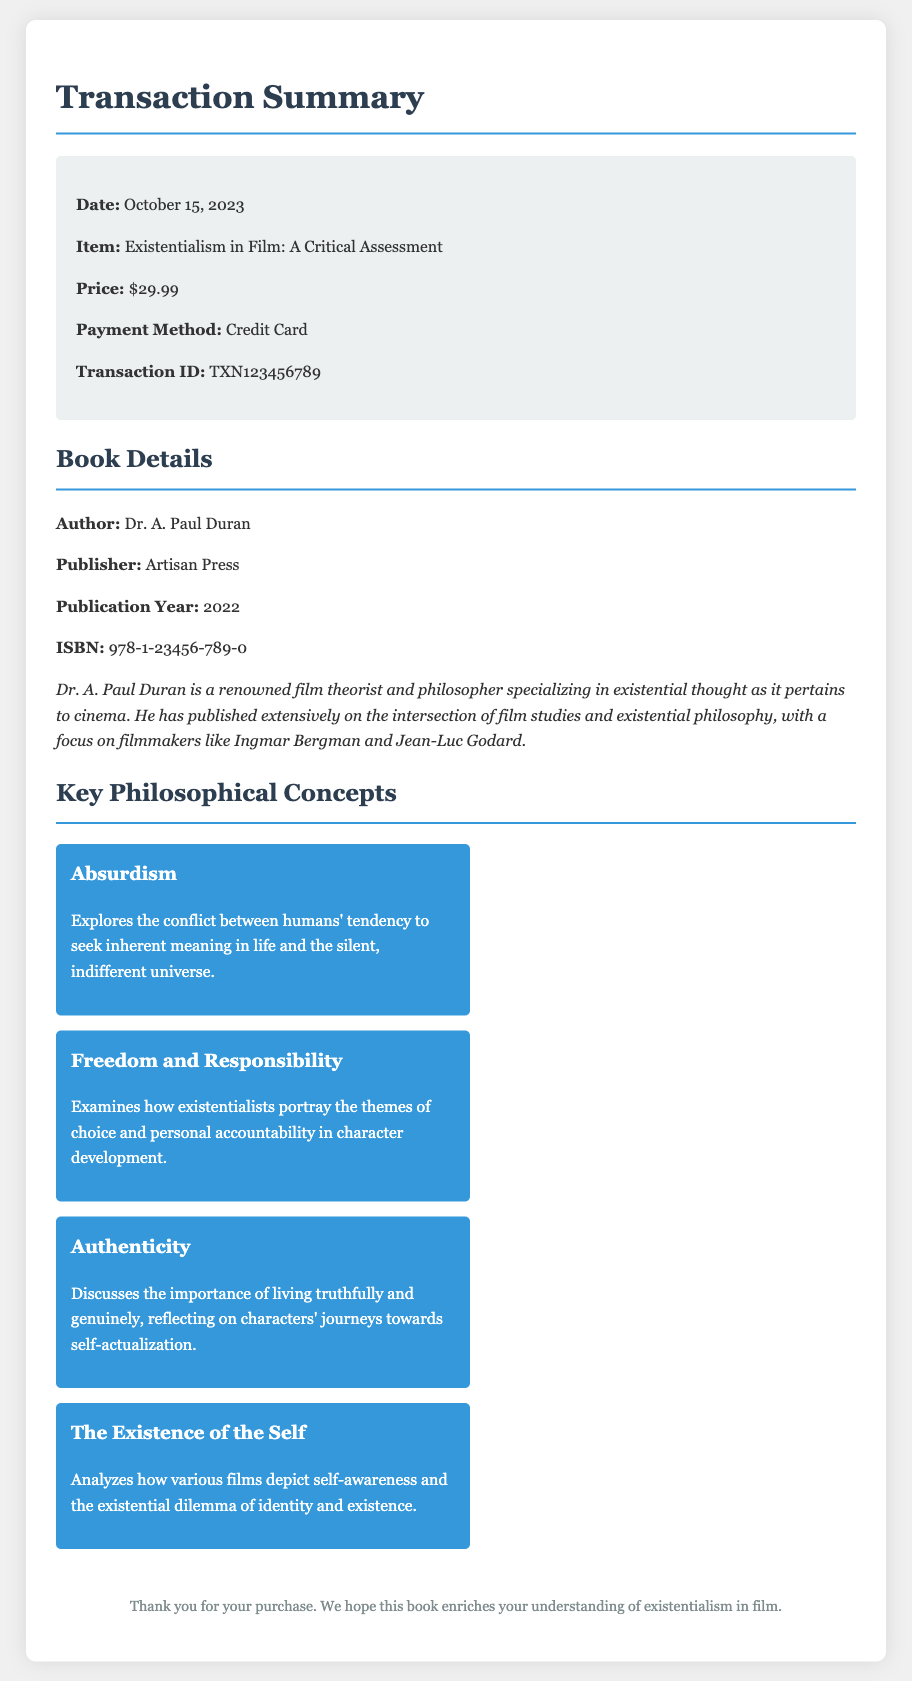What is the transaction date? The transaction date is explicitly mentioned in the document under the transaction details section.
Answer: October 15, 2023 Who is the author of the book? The author of the book is highlighted in the book details section of the document.
Answer: Dr. A. Paul Duran What is the price of the book? The price of the book can be found in the transaction details section.
Answer: $29.99 What philosophical concept examines the conflict between seeking meaning and an indifferent universe? The key concepts are discussed in the key philosophical concepts section, mentioning this specific concept.
Answer: Absurdism Which publisher released the book? The publisher's name is indicated in the book details section of the document.
Answer: Artisan Press What is one focus of Dr. A. Paul Duran's research? This information can be inferred from the author information section that discusses his specialization.
Answer: Existential thought What does the concept of authenticity discuss in the book? The description provides insight into what this concept entails, particularly regarding personal journeys.
Answer: Living truthfully What is the ISBN of the book? The ISBN number is specified in the book details section.
Answer: 978-1-23456-789-0 